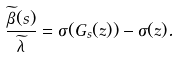Convert formula to latex. <formula><loc_0><loc_0><loc_500><loc_500>\frac { \widetilde { \beta } ( s ) } { \widetilde { \lambda } } = \sigma ( G _ { s } ( z ) ) - \sigma ( z ) .</formula> 